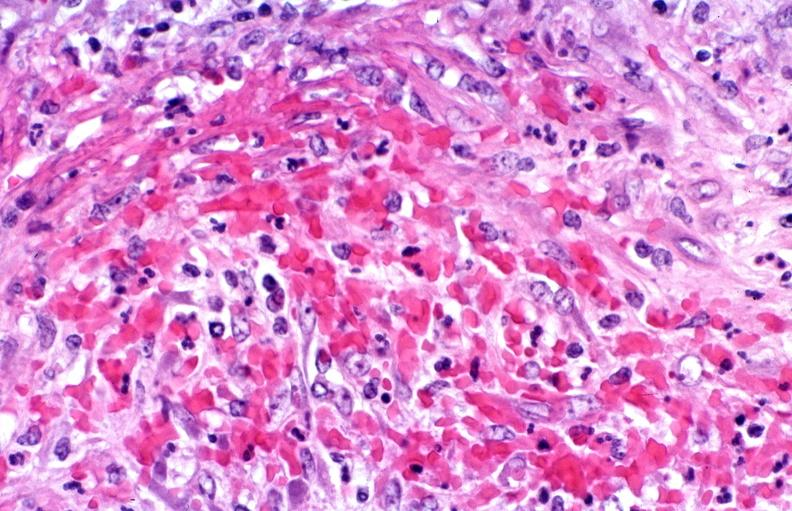does this image show polyarteritis nodosa?
Answer the question using a single word or phrase. Yes 